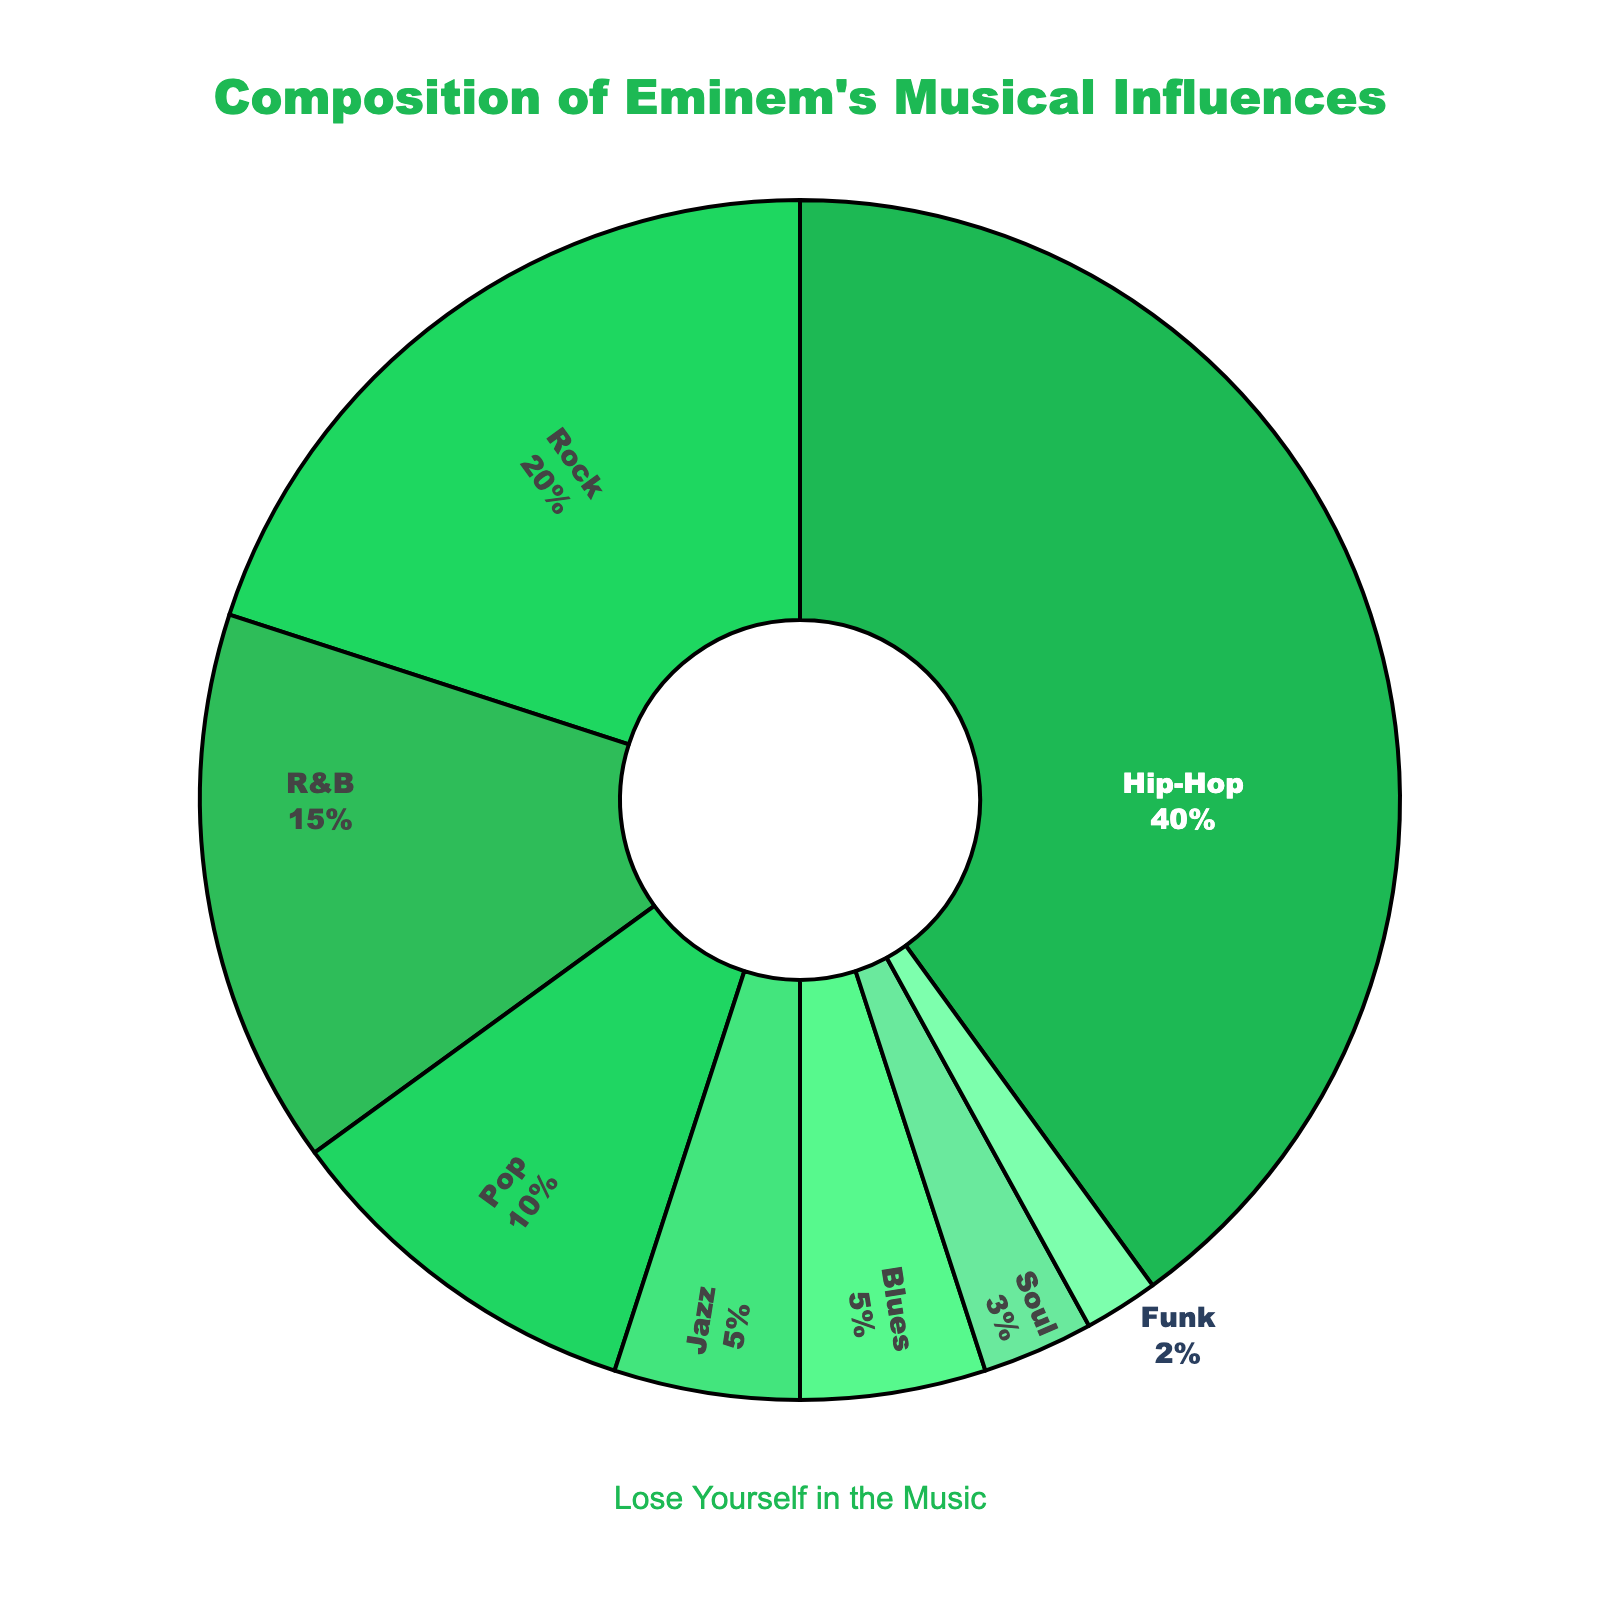What are the two most prominent genres among Eminem's musical influences? The pie chart visually depicts the distribution of various genres in Eminem's musical influences. Hip-Hop holds the largest segment of 40%, followed by Rock at 20%.
Answer: Hip-Hop and Rock How much larger is Hip-Hop's influence compared to Funk's influence? First, identify the percentage of Hip-Hop, which is 40%. Then, identify the percentage of Funk, which is 2%. Subtract Funk's percentage from Hip-Hop's percentage: 40% - 2% = 38%.
Answer: 38% What's the combined influence of R&B, Blues, and Jazz genres on Eminem? Sum the percentages for R&B (15%), Blues (5%), and Jazz (5%): 15% + 5% + 5% = 25%.
Answer: 25% Which genre has a larger influence, Pop or R&B, and by how much? Pop accounts for 10% while R&B accounts for 15%. Subtract the percentage of Pop from R&B: 15% - 10% = 5%.
Answer: R&B by 5% Can you rank the influences of Soul, Funk, and Blues from highest to lowest? According to the pie chart, the percentages are Blues (5%), Soul (3%), and Funk (2%). Ranking them from highest to lowest would be Blues > Soul > Funk.
Answer: Blues, Soul, Funk Is the combined percentage of Rock, R&B, and Jazz greater than the percentage of Hip-Hop alone? Calculate the sum of Rock (20%), R&B (15%), and Jazz (5%): 20% + 15% + 5% = 40%. Compare it to the percentage of Hip-Hop, which is also 40%. They are equal.
Answer: No, they are equal What percentage of Eminem's influences come from non-Hip-Hop genres? Subtract Hip-Hop's percentage (40%) from 100%: 100% - 40% = 60%.
Answer: 60% How does the visual representation highlight the top genre's influence? The pie chart visually shows that Hip-Hop occupies the largest segment of the pie, colored distinctly, making it easily recognizable as the top genre with 40% influence.
Answer: Largest segment, colored distinctly Which genre has the smallest influence on Eminem, and what is its percentage? The pie chart shows that Funk has the smallest segment with an influence of 2%.
Answer: Funk, 2% 